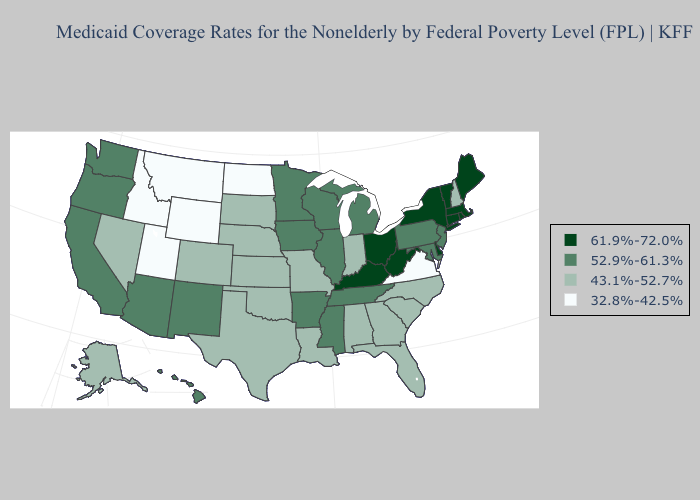Which states have the lowest value in the USA?
Short answer required. Idaho, Montana, North Dakota, Utah, Virginia, Wyoming. Among the states that border Mississippi , which have the highest value?
Answer briefly. Arkansas, Tennessee. Name the states that have a value in the range 52.9%-61.3%?
Quick response, please. Arizona, Arkansas, California, Hawaii, Illinois, Iowa, Maryland, Michigan, Minnesota, Mississippi, New Jersey, New Mexico, Oregon, Pennsylvania, Tennessee, Washington, Wisconsin. Does Colorado have the highest value in the USA?
Answer briefly. No. What is the value of New Hampshire?
Concise answer only. 43.1%-52.7%. What is the lowest value in the West?
Answer briefly. 32.8%-42.5%. Is the legend a continuous bar?
Short answer required. No. What is the value of Arizona?
Write a very short answer. 52.9%-61.3%. Name the states that have a value in the range 61.9%-72.0%?
Short answer required. Connecticut, Delaware, Kentucky, Maine, Massachusetts, New York, Ohio, Rhode Island, Vermont, West Virginia. What is the lowest value in the Northeast?
Short answer required. 43.1%-52.7%. Does the first symbol in the legend represent the smallest category?
Give a very brief answer. No. What is the lowest value in the South?
Answer briefly. 32.8%-42.5%. What is the value of Utah?
Answer briefly. 32.8%-42.5%. Does South Dakota have the lowest value in the USA?
Write a very short answer. No. Name the states that have a value in the range 43.1%-52.7%?
Give a very brief answer. Alabama, Alaska, Colorado, Florida, Georgia, Indiana, Kansas, Louisiana, Missouri, Nebraska, Nevada, New Hampshire, North Carolina, Oklahoma, South Carolina, South Dakota, Texas. 